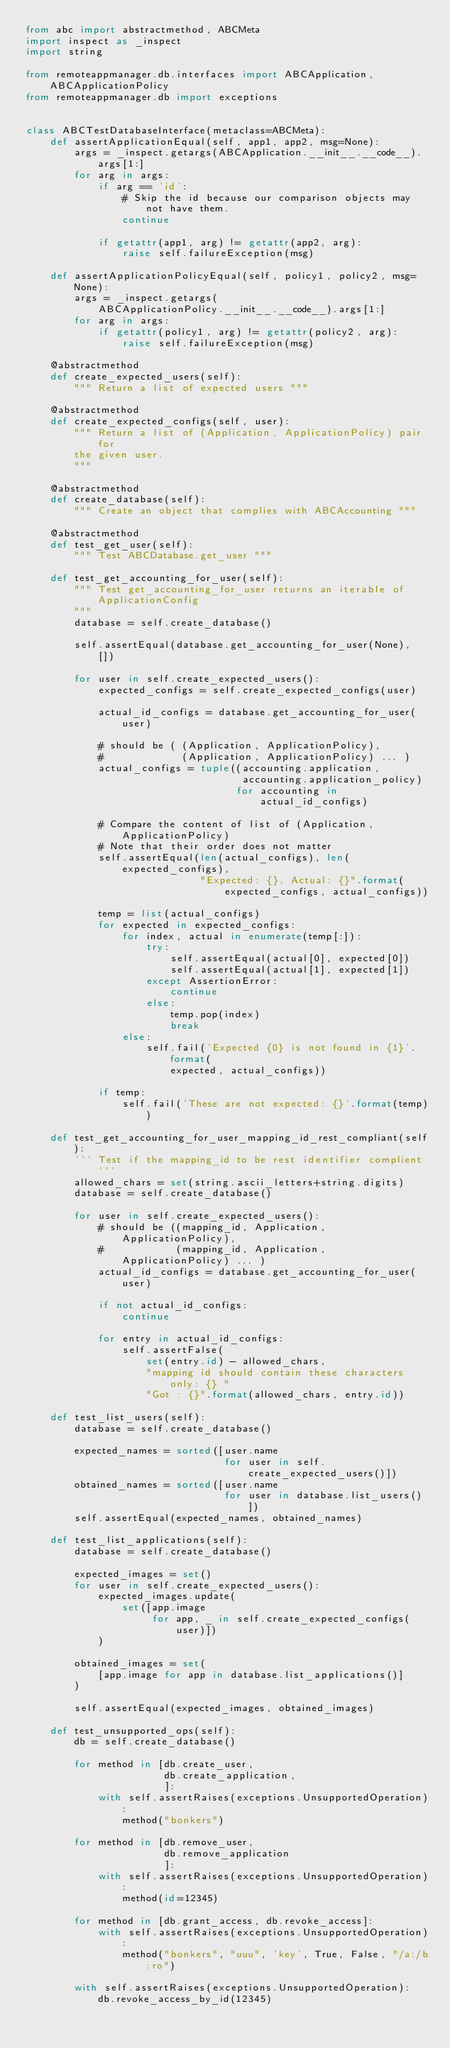<code> <loc_0><loc_0><loc_500><loc_500><_Python_>from abc import abstractmethod, ABCMeta
import inspect as _inspect
import string

from remoteappmanager.db.interfaces import ABCApplication, ABCApplicationPolicy
from remoteappmanager.db import exceptions


class ABCTestDatabaseInterface(metaclass=ABCMeta):
    def assertApplicationEqual(self, app1, app2, msg=None):
        args = _inspect.getargs(ABCApplication.__init__.__code__).args[1:]
        for arg in args:
            if arg == 'id':
                # Skip the id because our comparison objects may not have them.
                continue

            if getattr(app1, arg) != getattr(app2, arg):
                raise self.failureException(msg)

    def assertApplicationPolicyEqual(self, policy1, policy2, msg=None):
        args = _inspect.getargs(
            ABCApplicationPolicy.__init__.__code__).args[1:]
        for arg in args:
            if getattr(policy1, arg) != getattr(policy2, arg):
                raise self.failureException(msg)

    @abstractmethod
    def create_expected_users(self):
        """ Return a list of expected users """

    @abstractmethod
    def create_expected_configs(self, user):
        """ Return a list of (Application, ApplicationPolicy) pair for
        the given user.
        """

    @abstractmethod
    def create_database(self):
        """ Create an object that complies with ABCAccounting """

    @abstractmethod
    def test_get_user(self):
        """ Test ABCDatabase.get_user """

    def test_get_accounting_for_user(self):
        """ Test get_accounting_for_user returns an iterable of ApplicationConfig
        """
        database = self.create_database()

        self.assertEqual(database.get_accounting_for_user(None), [])

        for user in self.create_expected_users():
            expected_configs = self.create_expected_configs(user)

            actual_id_configs = database.get_accounting_for_user(user)

            # should be ( (Application, ApplicationPolicy),
            #             (Application, ApplicationPolicy) ... )
            actual_configs = tuple((accounting.application,
                                    accounting.application_policy)
                                   for accounting in actual_id_configs)

            # Compare the content of list of (Application, ApplicationPolicy)
            # Note that their order does not matter
            self.assertEqual(len(actual_configs), len(expected_configs),
                             "Expected: {}, Actual: {}".format(
                                 expected_configs, actual_configs))

            temp = list(actual_configs)
            for expected in expected_configs:
                for index, actual in enumerate(temp[:]):
                    try:
                        self.assertEqual(actual[0], expected[0])
                        self.assertEqual(actual[1], expected[1])
                    except AssertionError:
                        continue
                    else:
                        temp.pop(index)
                        break
                else:
                    self.fail('Expected {0} is not found in {1}'.format(
                        expected, actual_configs))

            if temp:
                self.fail('These are not expected: {}'.format(temp))

    def test_get_accounting_for_user_mapping_id_rest_compliant(self):
        ''' Test if the mapping_id to be rest identifier complient '''
        allowed_chars = set(string.ascii_letters+string.digits)
        database = self.create_database()

        for user in self.create_expected_users():
            # should be ((mapping_id, Application, ApplicationPolicy),
            #            (mapping_id, Application, ApplicationPolicy) ... )
            actual_id_configs = database.get_accounting_for_user(user)

            if not actual_id_configs:
                continue

            for entry in actual_id_configs:
                self.assertFalse(
                    set(entry.id) - allowed_chars,
                    "mapping id should contain these characters only: {} "
                    "Got : {}".format(allowed_chars, entry.id))

    def test_list_users(self):
        database = self.create_database()

        expected_names = sorted([user.name
                                 for user in self.create_expected_users()])
        obtained_names = sorted([user.name
                                 for user in database.list_users()])
        self.assertEqual(expected_names, obtained_names)

    def test_list_applications(self):
        database = self.create_database()

        expected_images = set()
        for user in self.create_expected_users():
            expected_images.update(
                set([app.image
                     for app, _ in self.create_expected_configs(user)])
            )

        obtained_images = set(
            [app.image for app in database.list_applications()]
        )

        self.assertEqual(expected_images, obtained_images)

    def test_unsupported_ops(self):
        db = self.create_database()

        for method in [db.create_user,
                       db.create_application,
                       ]:
            with self.assertRaises(exceptions.UnsupportedOperation):
                method("bonkers")

        for method in [db.remove_user,
                       db.remove_application
                       ]:
            with self.assertRaises(exceptions.UnsupportedOperation):
                method(id=12345)

        for method in [db.grant_access, db.revoke_access]:
            with self.assertRaises(exceptions.UnsupportedOperation):
                method("bonkers", "uuu", 'key', True, False, "/a:/b:ro")

        with self.assertRaises(exceptions.UnsupportedOperation):
            db.revoke_access_by_id(12345)
</code> 